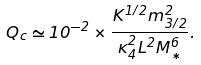Convert formula to latex. <formula><loc_0><loc_0><loc_500><loc_500>Q _ { c } \simeq 1 0 ^ { - 2 } \times \frac { K ^ { 1 / 2 } m _ { 3 / 2 } ^ { 2 } } { \kappa _ { 4 } ^ { 2 } L ^ { 2 } M _ { * } ^ { 6 } } .</formula> 